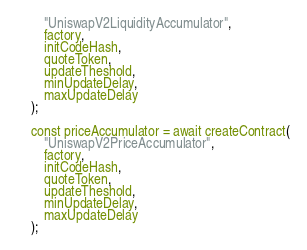Convert code to text. <code><loc_0><loc_0><loc_500><loc_500><_JavaScript_>        "UniswapV2LiquidityAccumulator",
        factory,
        initCodeHash,
        quoteToken,
        updateTheshold,
        minUpdateDelay,
        maxUpdateDelay
    );

    const priceAccumulator = await createContract(
        "UniswapV2PriceAccumulator",
        factory,
        initCodeHash,
        quoteToken,
        updateTheshold,
        minUpdateDelay,
        maxUpdateDelay
    );
</code> 